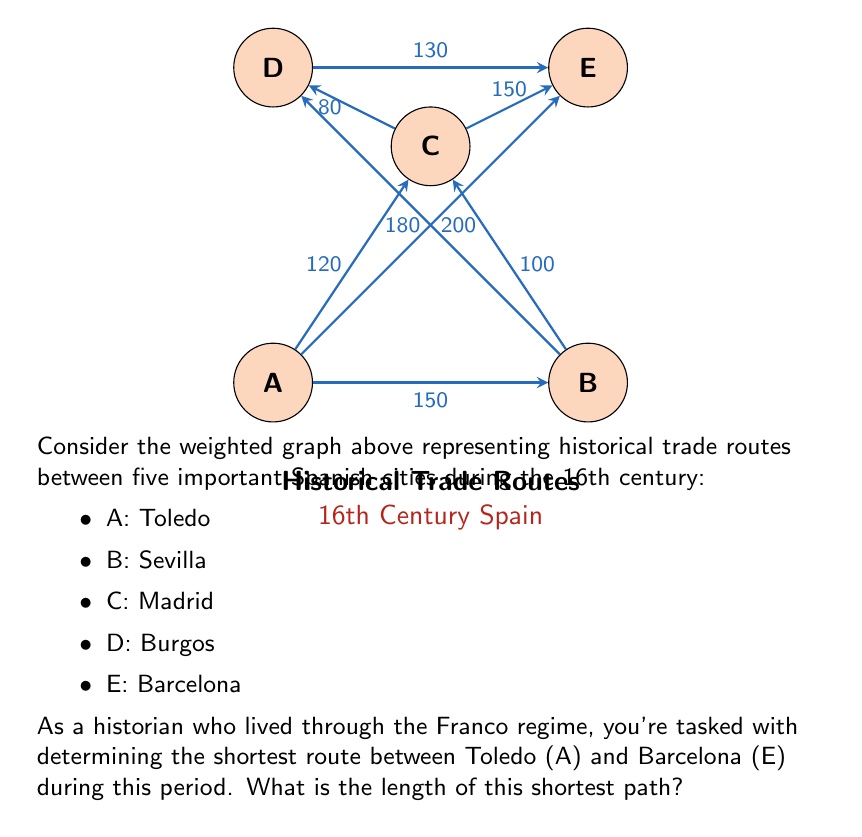Help me with this question. To solve this problem, we'll use Dijkstra's algorithm, a method developed in 1956 which would have been relatively new during the early years of Franco's regime.

Let's follow the steps:

1) Initialize:
   - Distance to A (Toledo) = 0
   - Distance to all other vertices = $\infty$

2) Start from A (Toledo):
   - Update neighbors:
     B (Sevilla): 150
     C (Madrid): 120
     E (Barcelona): 200

3) Select the vertex with the smallest distance (C = 120):
   - Update neighbors:
     D (Burgos): 120 + 80 = 200
     E (Barcelona): min(200, 120 + 150) = 200

4) Select the next smallest (B = 150):
   - Update neighbors:
     D (Burgos): min(200, 150 + 180) = 200

5) Select the next smallest (E = 200):
   - This is our destination, so we stop.

The shortest path from Toledo to Barcelona is A-C-E with a total length of 120 + 150 = 270.
Answer: 270 